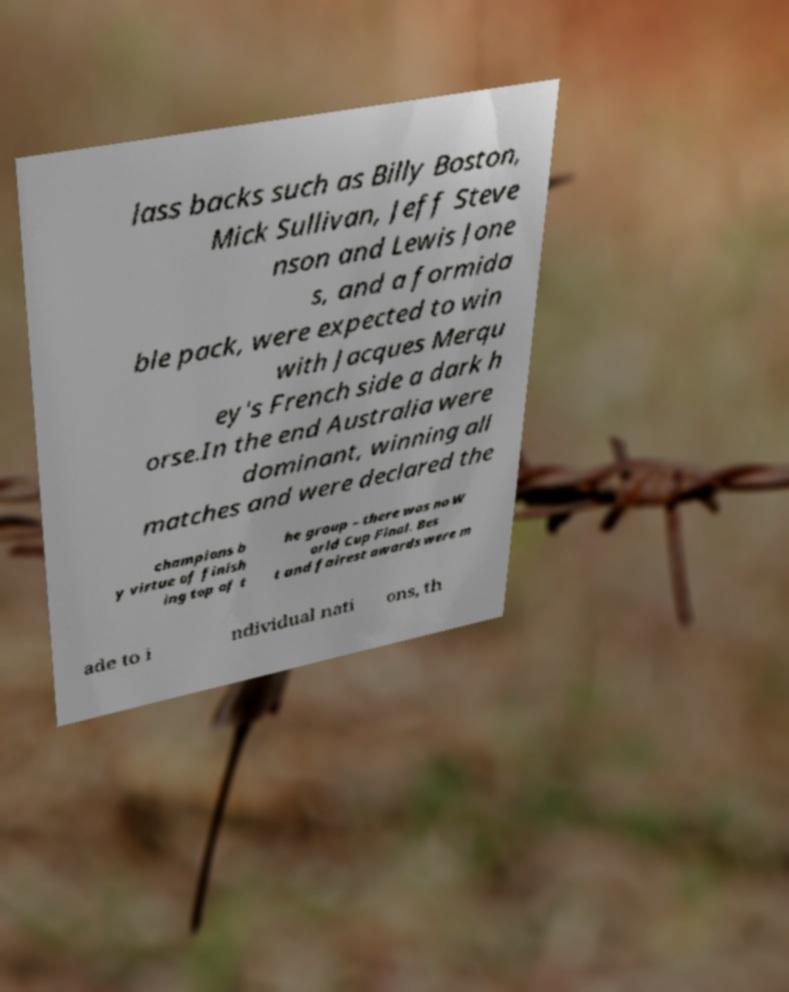Please read and relay the text visible in this image. What does it say? lass backs such as Billy Boston, Mick Sullivan, Jeff Steve nson and Lewis Jone s, and a formida ble pack, were expected to win with Jacques Merqu ey's French side a dark h orse.In the end Australia were dominant, winning all matches and were declared the champions b y virtue of finish ing top of t he group – there was no W orld Cup Final. Bes t and fairest awards were m ade to i ndividual nati ons, th 